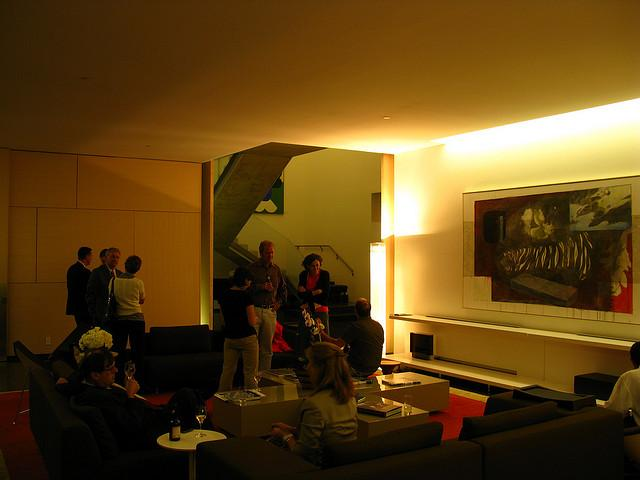What is the design of the staircase called?

Choices:
A) tall staircase
B) l-shaped staircase
C) turning staircase
D) curved staircase l-shaped staircase 